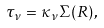<formula> <loc_0><loc_0><loc_500><loc_500>\tau _ { \nu } = \kappa _ { \nu } \Sigma ( R ) \, ,</formula> 